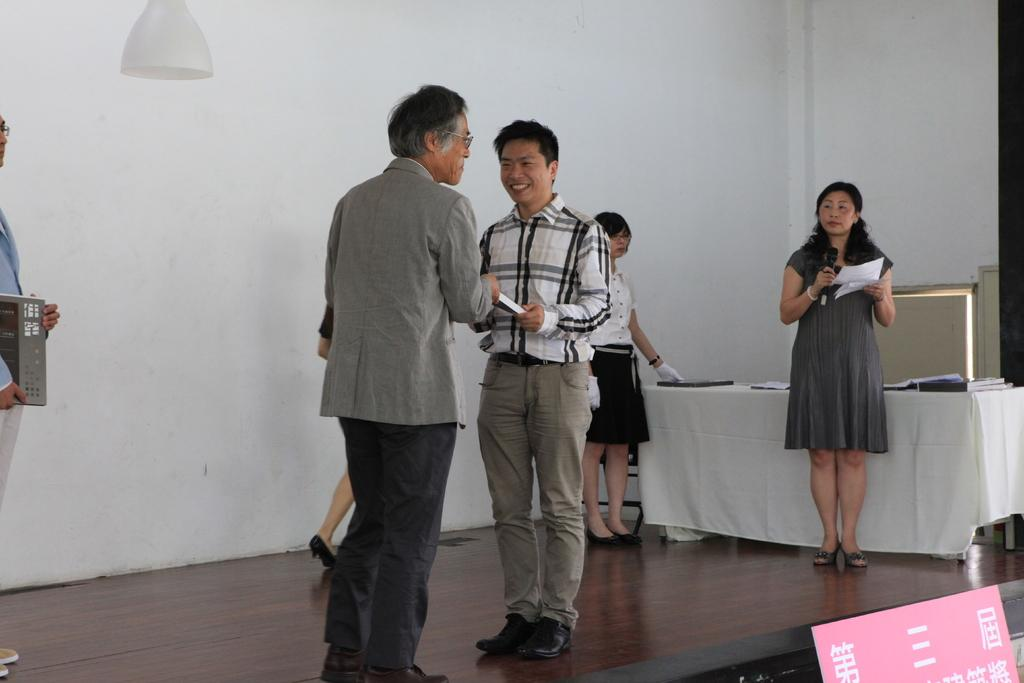How many people are in the image? There is a group of people in the image. What are the people in the image doing? The people are standing. What can be seen on the table in the background? There are books and other things on a table in the background. What is visible in the background of the image? There is a wall visible in the background. Can you tell me how many rabbits are hopping around in the image? There are no rabbits present in the image. What historical event is being discussed by the people in the image? There is no indication of a historical event being discussed in the image. 